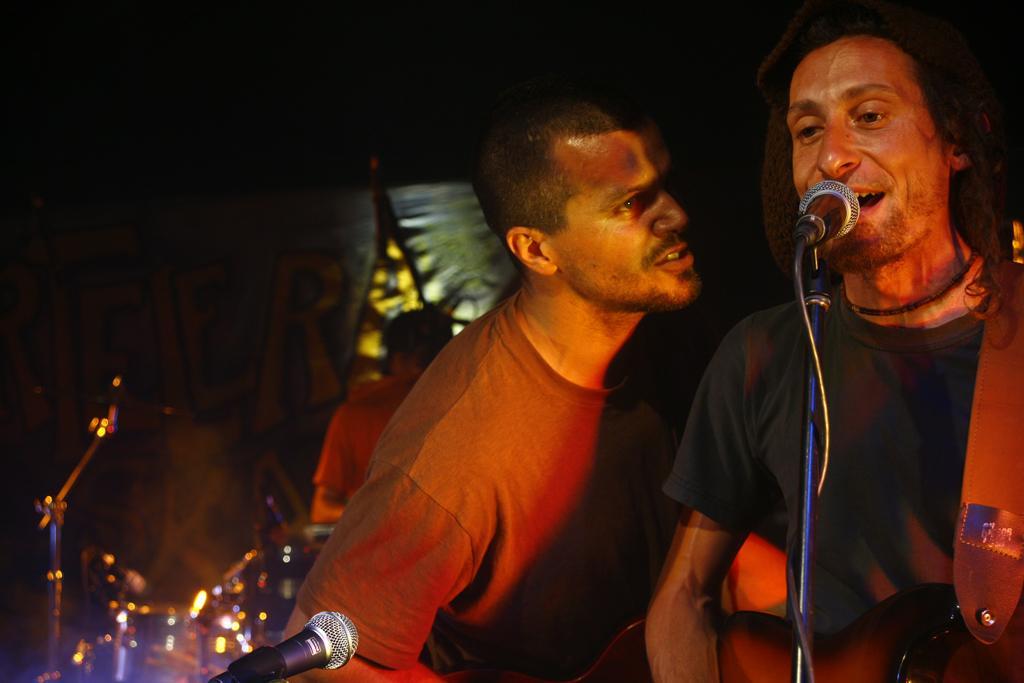Describe this image in one or two sentences. A man is singing with a mic in front of him. He is holding a guitar. There is another man standing beside him. In the background a man is playing drums. 